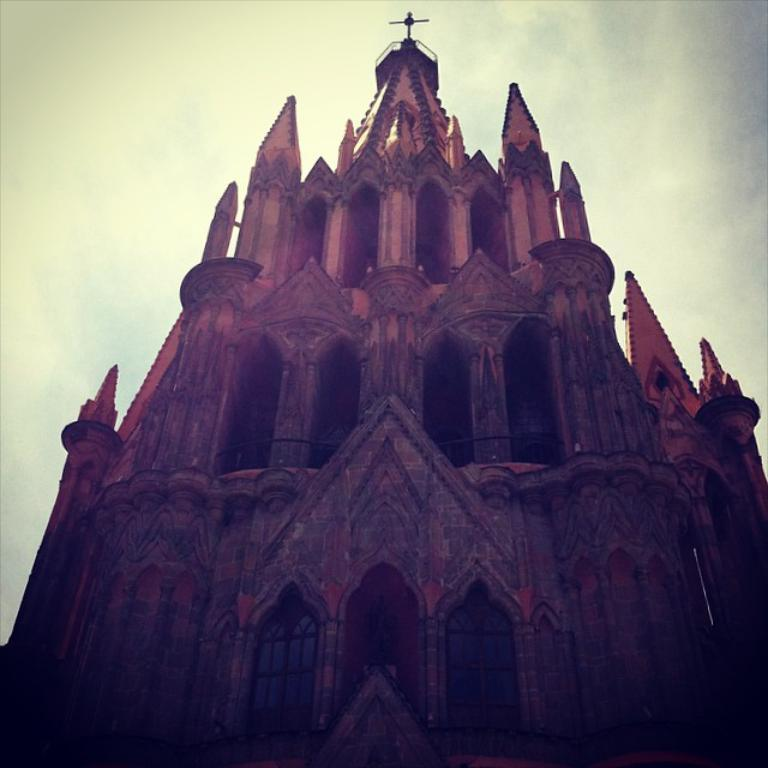What is the main structure in the center of the image? There is a fort in the center of the image. What can be seen in the background of the image? There is sky visible in the background of the image. How does the mother feel about the friction in the image? There is no mother or friction present in the image, so it is not possible to answer that question. 